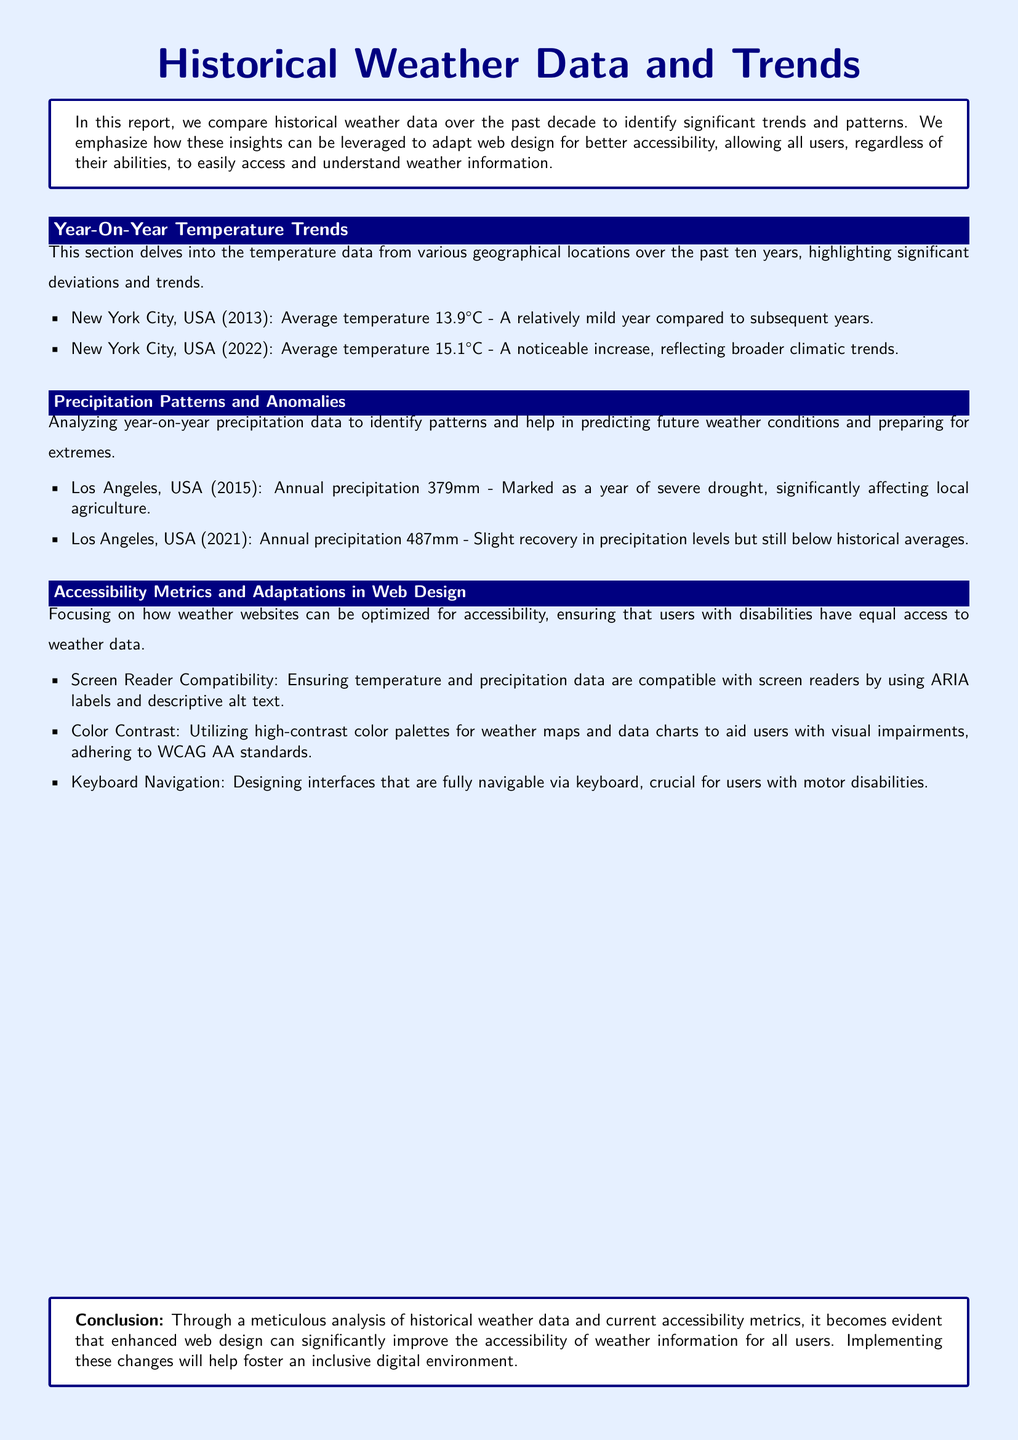What was the average temperature in New York City in 2013? The average temperature for New York City in 2013 was stated in the document as 13.9°C.
Answer: 13.9°C What was the annual precipitation in Los Angeles in 2015? The document records that Los Angeles had an annual precipitation of 379mm in 2015.
Answer: 379mm What is one way to improve screen reader compatibility for weather data? The document suggests using ARIA labels and descriptive alt text for improving compatibility.
Answer: ARIA labels and descriptive alt text How much did the average temperature in New York City increase from 2013 to 2022? By comparing the temperatures, the increase is calculated as 15.1°C - 13.9°C.
Answer: 1.2°C What happened in Los Angeles during the year 2015? The document mentions it as a year of severe drought affecting local agriculture.
Answer: Severe drought What accessibility standard is emphasized for color contrast in web design? The document refers to adhering to WCAG AA standards for color contrast.
Answer: WCAG AA standards What is the title of the report? The title given at the beginning of the document is "Historical Weather Data and Trends."
Answer: Historical Weather Data and Trends Which aspect of weather websites does the document specifically focus on to improve user experience? The document focuses on optimizing websites for accessibility to accommodate all users with disabilities.
Answer: Accessibility What is the average temperature recorded for New York City in 2022? The document states that the average temperature for New York City in 2022 was 15.1°C.
Answer: 15.1°C 